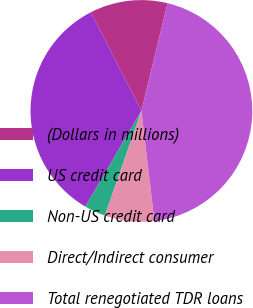Convert chart to OTSL. <chart><loc_0><loc_0><loc_500><loc_500><pie_chart><fcel>(Dollars in millions)<fcel>US credit card<fcel>Non-US credit card<fcel>Direct/Indirect consumer<fcel>Total renegotiated TDR loans<nl><fcel>11.34%<fcel>34.02%<fcel>3.09%<fcel>7.22%<fcel>44.33%<nl></chart> 